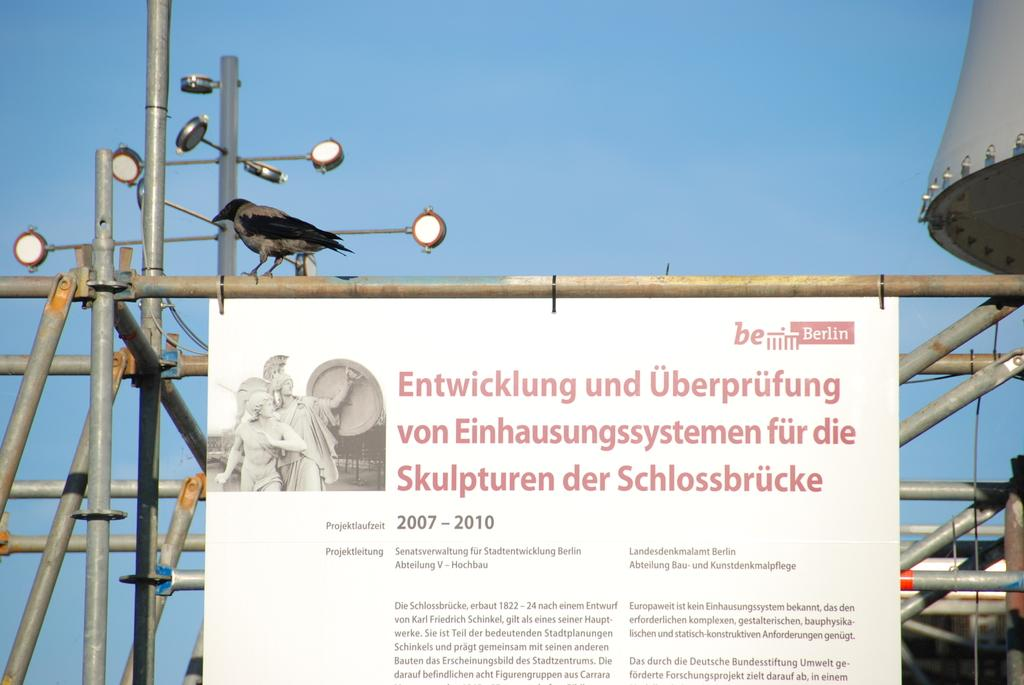<image>
Give a short and clear explanation of the subsequent image. A white board with red lettering in Geman posted to a metal pole. 